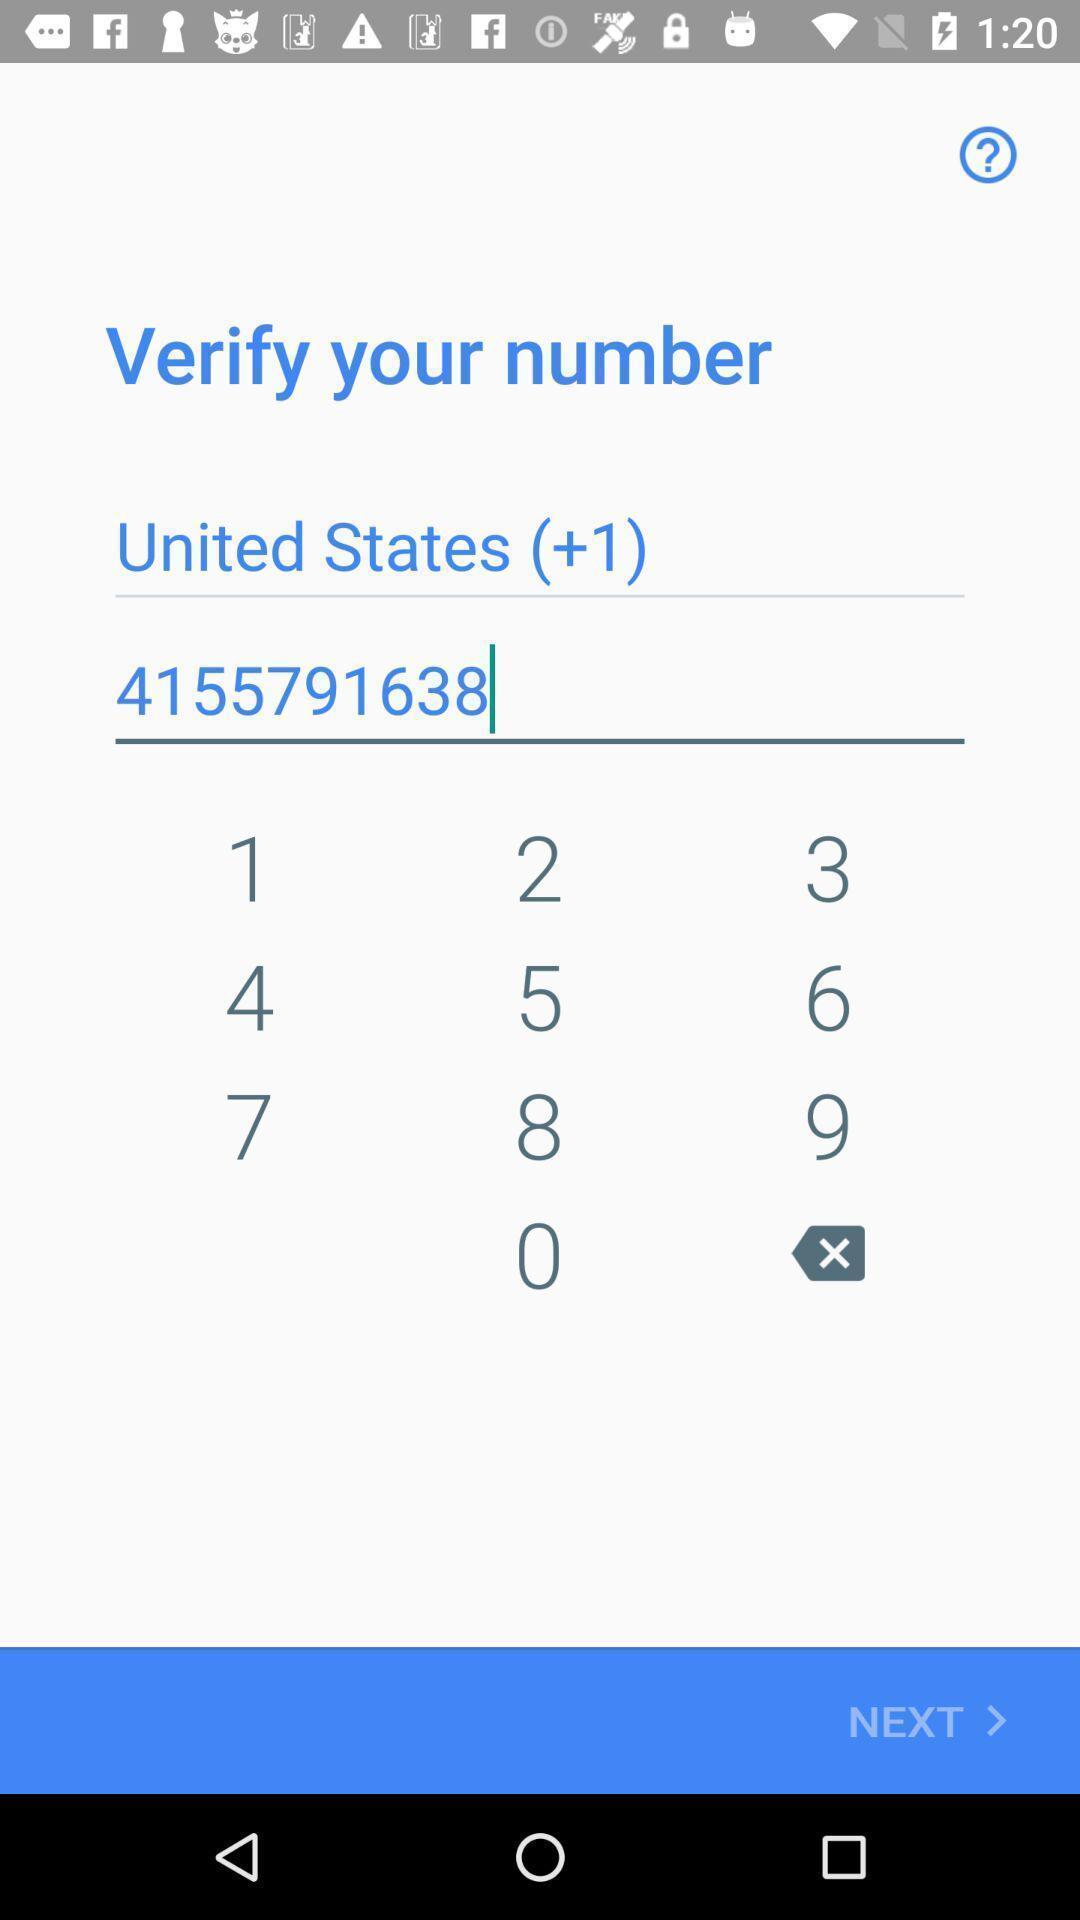Describe the content in this image. Screen showing verification page of a number. 